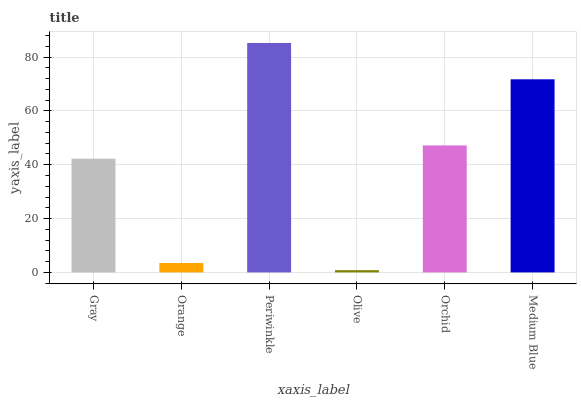Is Orange the minimum?
Answer yes or no. No. Is Orange the maximum?
Answer yes or no. No. Is Gray greater than Orange?
Answer yes or no. Yes. Is Orange less than Gray?
Answer yes or no. Yes. Is Orange greater than Gray?
Answer yes or no. No. Is Gray less than Orange?
Answer yes or no. No. Is Orchid the high median?
Answer yes or no. Yes. Is Gray the low median?
Answer yes or no. Yes. Is Medium Blue the high median?
Answer yes or no. No. Is Periwinkle the low median?
Answer yes or no. No. 